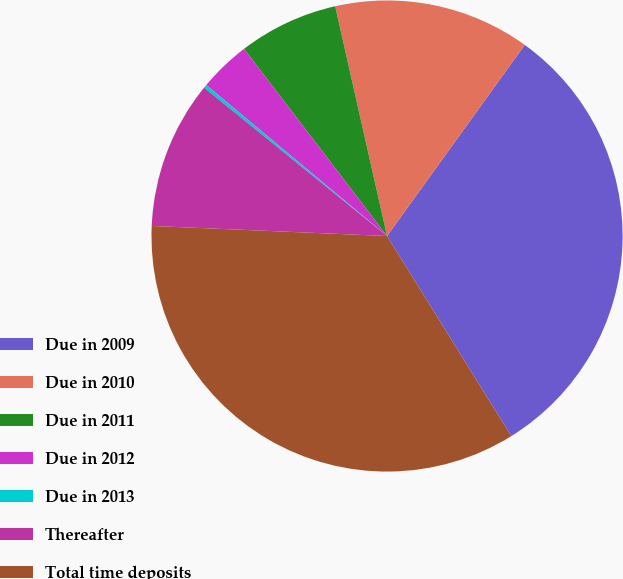<chart> <loc_0><loc_0><loc_500><loc_500><pie_chart><fcel>Due in 2009<fcel>Due in 2010<fcel>Due in 2011<fcel>Due in 2012<fcel>Due in 2013<fcel>Thereafter<fcel>Total time deposits<nl><fcel>31.21%<fcel>13.47%<fcel>6.85%<fcel>3.54%<fcel>0.23%<fcel>10.16%<fcel>34.52%<nl></chart> 